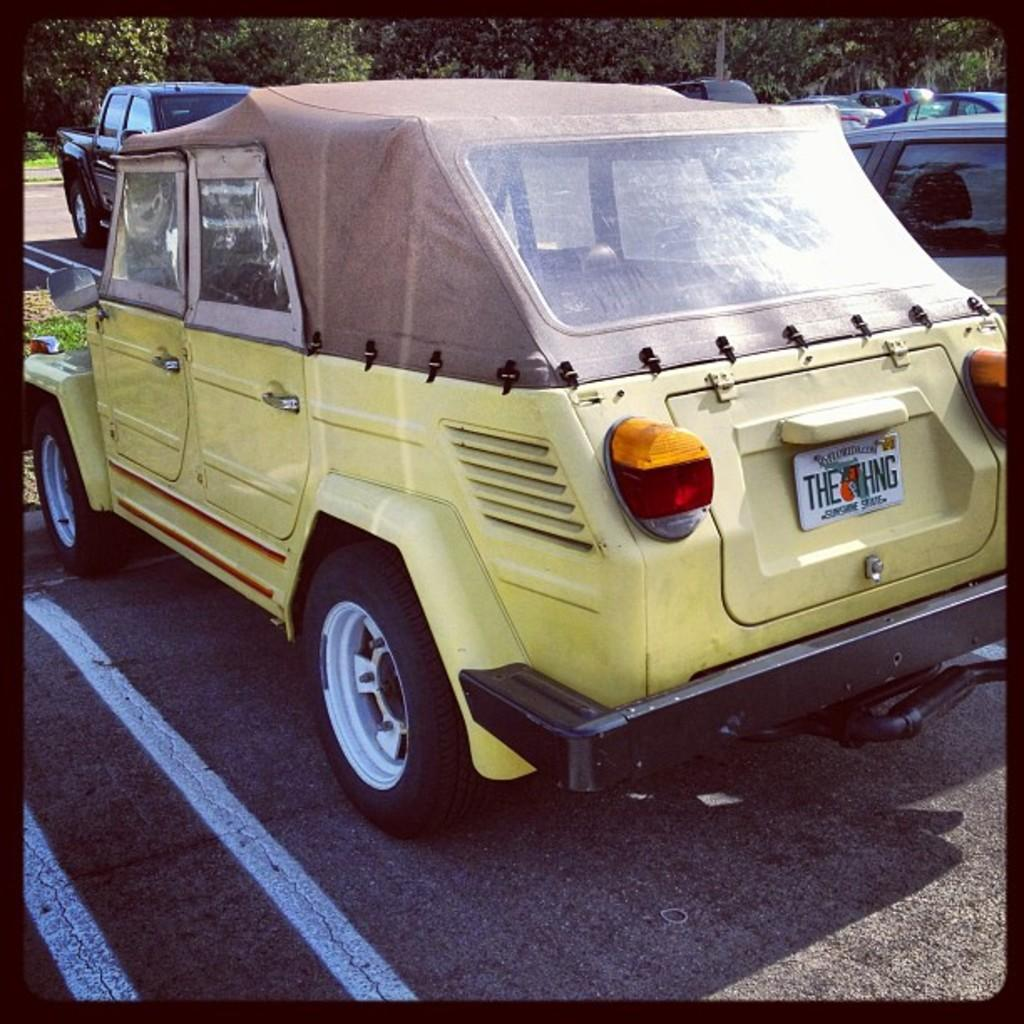What types of objects can be seen in the image? There are vehicles in the image. What natural elements are present in the image? There are trees and grass visible in the image. What part of the environment can be seen in the image? The ground is visible in the image. What type of door can be seen in the image? There is no door present in the image. How does the lead affect the vehicles in the image? There is no mention of lead in the image, and therefore its effect on the vehicles cannot be determined. 